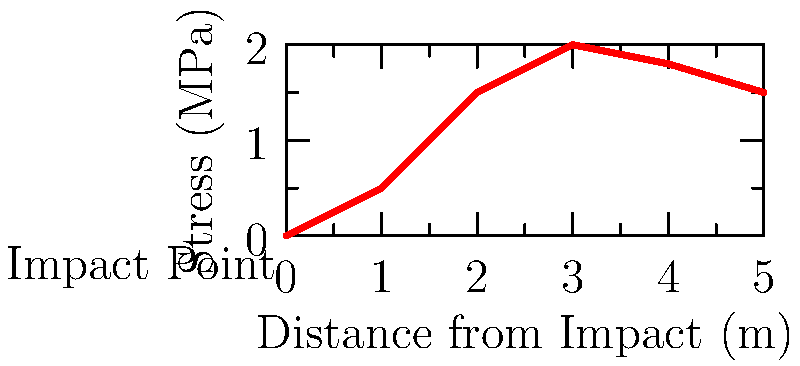Based on the stress distribution graph for a military vehicle's armor plating under impact, at what approximate distance from the impact point does the stress reach its maximum value? To determine the distance at which the stress reaches its maximum value, we need to analyze the graph:

1. The x-axis represents the distance from the impact point in meters.
2. The y-axis represents the stress in MPa.
3. The curve shows how the stress changes with distance from the impact point.

Examining the curve:
1. At x = 0 (impact point), the stress is 0 MPa.
2. The stress increases rapidly from 0 to 2 meters.
3. The curve reaches its peak at approximately 3 meters from the impact point.
4. After 3 meters, the stress begins to decrease.

Therefore, the maximum stress occurs at approximately 3 meters from the impact point.

This stress distribution is typical for armor plating, where the impact energy is distributed outward from the point of contact. The maximum stress often occurs slightly away from the impact point due to the complex wave propagation and material deformation in the armor.
Answer: 3 meters 